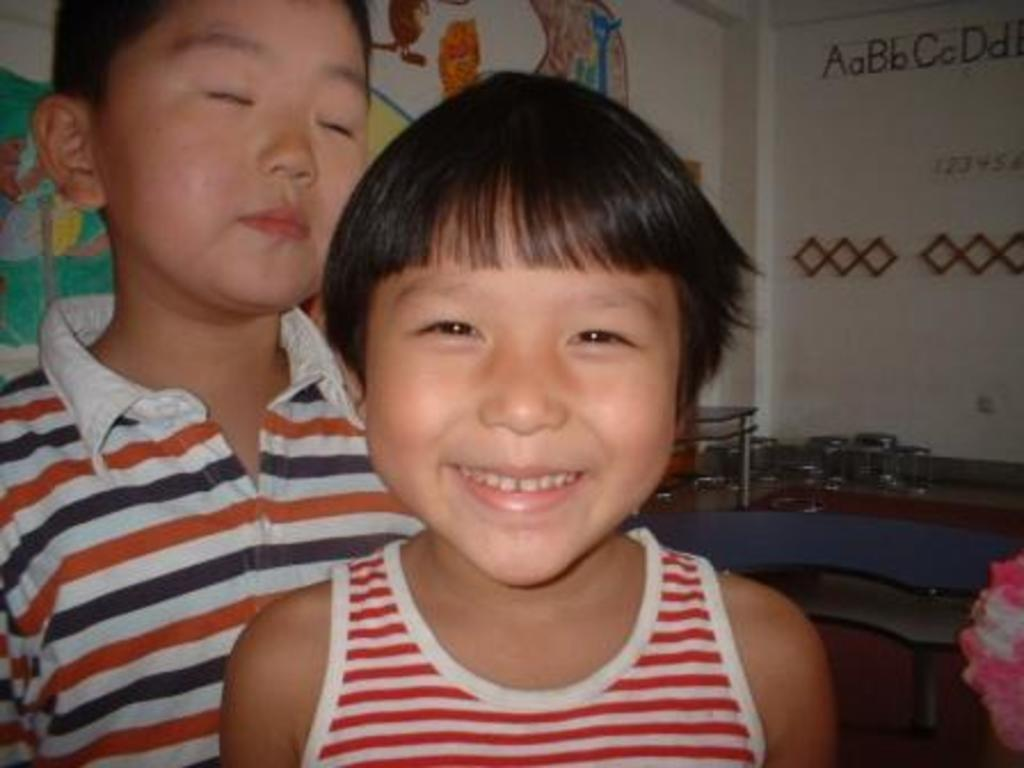How many kids are in the image? There are two kids in the image. Can you describe the expression of one of the kids? One of the kids is smiling. What can be seen in the background of the image? There is a painting on a wall and objects on a surface in the background. What type of digestion can be observed in the image? There is no digestion present in the image; it features two kids and a background with a painting and objects. 